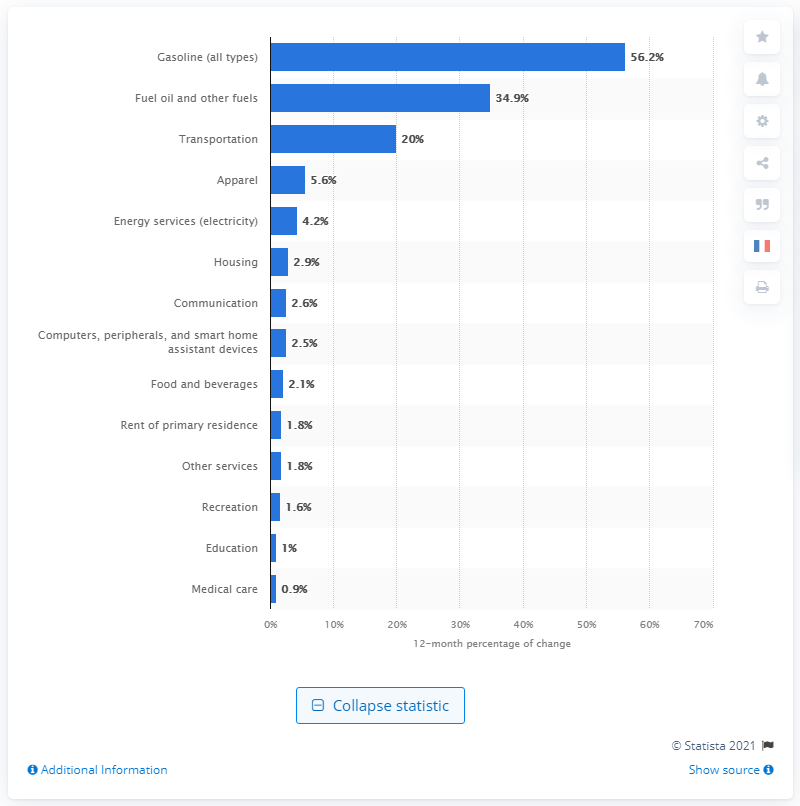List a handful of essential elements in this visual. In May 2021, gasoline prices were significantly higher than they were in May 2020, increasing by 56.2%. 